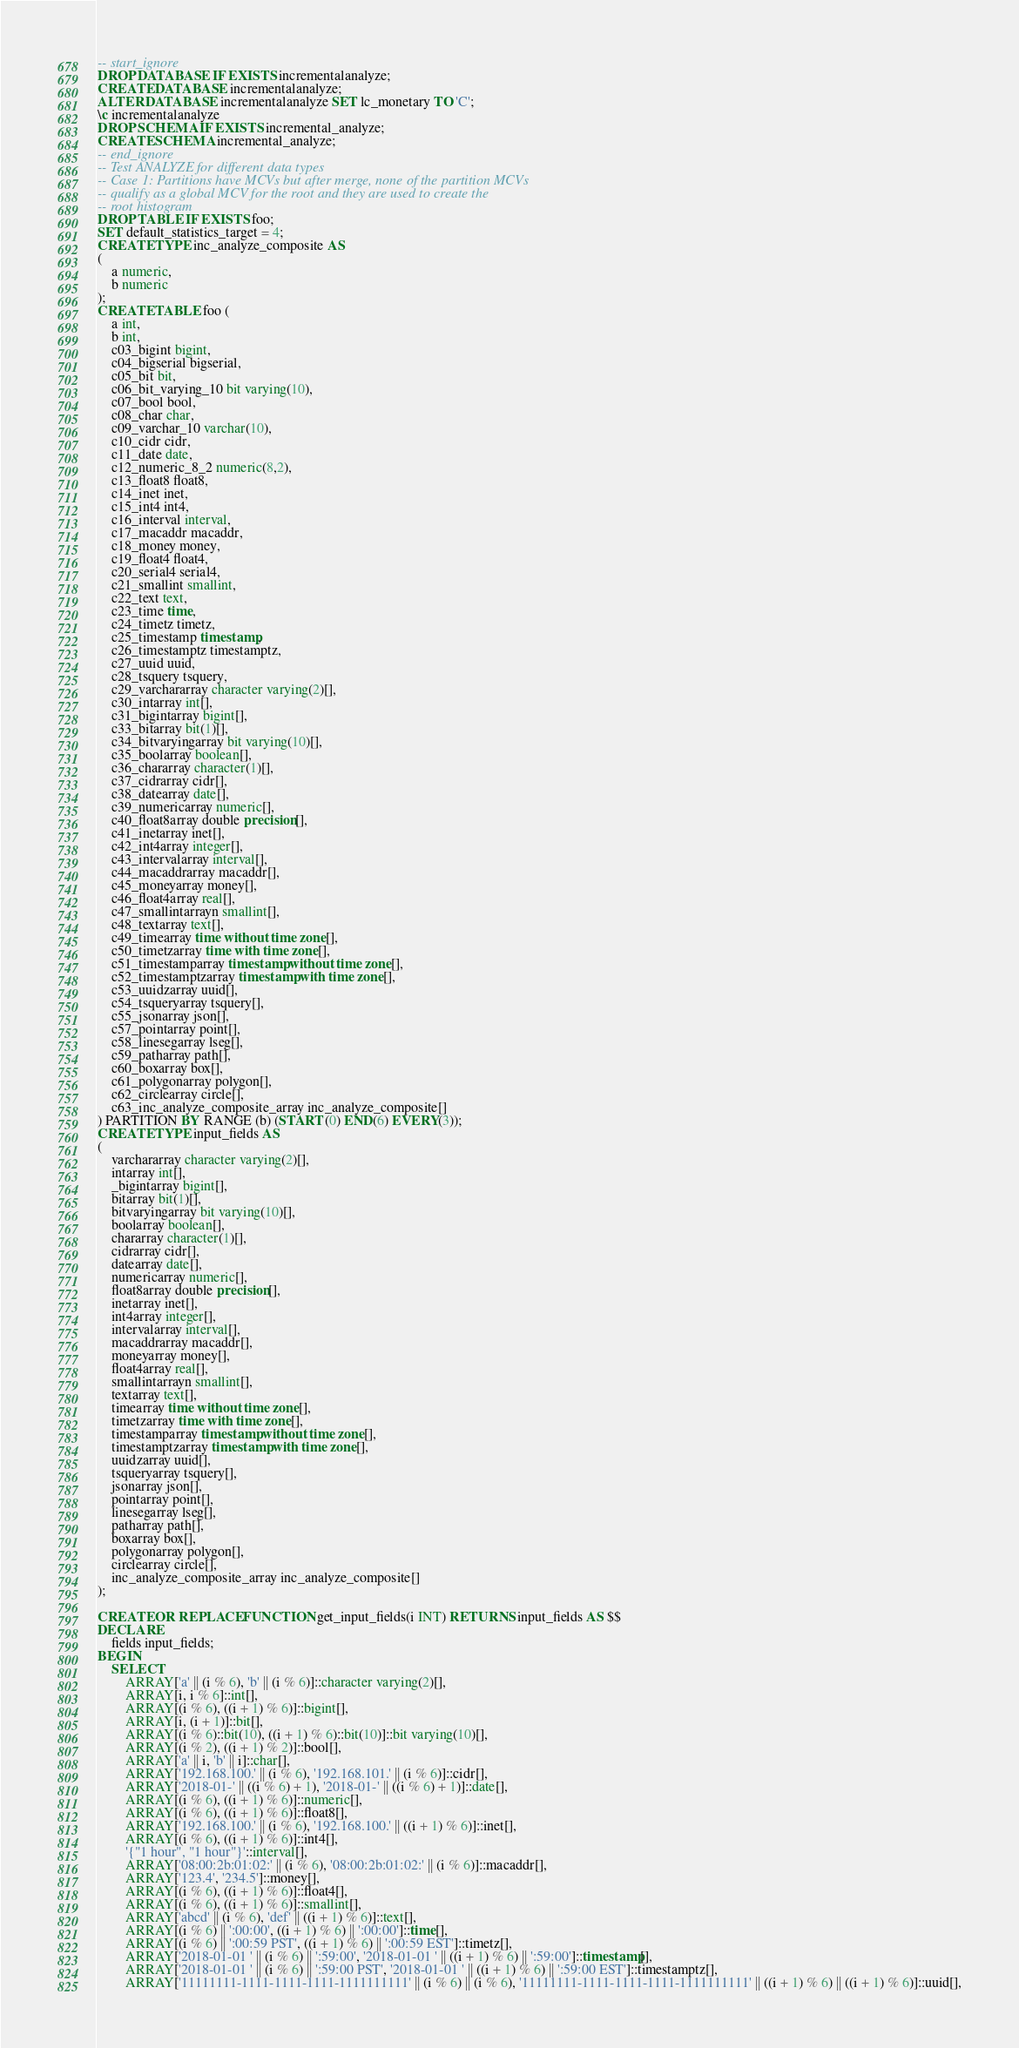Convert code to text. <code><loc_0><loc_0><loc_500><loc_500><_SQL_>-- start_ignore
DROP DATABASE IF EXISTS incrementalanalyze;
CREATE DATABASE incrementalanalyze;
ALTER DATABASE incrementalanalyze SET lc_monetary TO 'C';
\c incrementalanalyze
DROP SCHEMA IF EXISTS incremental_analyze;
CREATE SCHEMA incremental_analyze;
-- end_ignore
-- Test ANALYZE for different data types
-- Case 1: Partitions have MCVs but after merge, none of the partition MCVs 
-- qualify as a global MCV for the root and they are used to create the
-- root histogram
DROP TABLE IF EXISTS foo;
SET default_statistics_target = 4;
CREATE TYPE inc_analyze_composite AS
(
    a numeric,
    b numeric
);
CREATE TABLE foo (
    a int,
    b int, 
    c03_bigint bigint, 
    c04_bigserial bigserial, 
    c05_bit bit, 
    c06_bit_varying_10 bit varying(10), 
    c07_bool bool, 
    c08_char char, 
    c09_varchar_10 varchar(10), 
    c10_cidr cidr, 
    c11_date date, 
    c12_numeric_8_2 numeric(8,2), 
    c13_float8 float8, 
    c14_inet inet, 
    c15_int4 int4, 
    c16_interval interval, 
    c17_macaddr macaddr, 
    c18_money money, 
    c19_float4 float4, 
    c20_serial4 serial4, 
    c21_smallint smallint, 
    c22_text text, 
    c23_time time, 
    c24_timetz timetz, 
    c25_timestamp timestamp, 
    c26_timestamptz timestamptz,
    c27_uuid uuid,
    c28_tsquery tsquery,
    c29_varchararray character varying(2)[],
    c30_intarray int[],
    c31_bigintarray bigint[],
    c33_bitarray bit(1)[],
    c34_bitvaryingarray bit varying(10)[],
    c35_boolarray boolean[],
    c36_chararray character(1)[],
    c37_cidrarray cidr[],
    c38_datearray date[],
    c39_numericarray numeric[],
    c40_float8array double precision[],
    c41_inetarray inet[],
    c42_int4array integer[],
    c43_intervalarray interval[],
    c44_macaddrarray macaddr[],
    c45_moneyarray money[],
    c46_float4array real[],
    c47_smallintarrayn smallint[],
    c48_textarray text[],
    c49_timearray time without time zone[],
    c50_timetzarray time with time zone[],
    c51_timestamparray timestamp without time zone[],
    c52_timestamptzarray timestamp with time zone[],
    c53_uuidzarray uuid[],
    c54_tsqueryarray tsquery[],
    c55_jsonarray json[],
    c57_pointarray point[],
    c58_linesegarray lseg[],
    c59_patharray path[],
    c60_boxarray box[],
    c61_polygonarray polygon[],
    c62_circlearray circle[],
    c63_inc_analyze_composite_array inc_analyze_composite[]
) PARTITION BY RANGE (b) (START (0) END(6) EVERY(3));
CREATE TYPE input_fields AS
(
    varchararray character varying(2)[],
    intarray int[],
    _bigintarray bigint[],
    bitarray bit(1)[],
    bitvaryingarray bit varying(10)[],
    boolarray boolean[],
    chararray character(1)[],
    cidrarray cidr[],
    datearray date[],
    numericarray numeric[],
    float8array double precision[],
    inetarray inet[],
    int4array integer[],
    intervalarray interval[],
    macaddrarray macaddr[],
    moneyarray money[],
    float4array real[],
    smallintarrayn smallint[],
    textarray text[],
    timearray time without time zone[],
    timetzarray time with time zone[],
    timestamparray timestamp without time zone[],
    timestamptzarray timestamp with time zone[],
    uuidzarray uuid[],
    tsqueryarray tsquery[],
    jsonarray json[],
    pointarray point[],
    linesegarray lseg[],
    patharray path[],
    boxarray box[],
    polygonarray polygon[],
    circlearray circle[],
    inc_analyze_composite_array inc_analyze_composite[]
);

CREATE OR REPLACE FUNCTION get_input_fields(i INT) RETURNS input_fields AS $$
DECLARE
    fields input_fields;
BEGIN
    SELECT
        ARRAY['a' || (i % 6), 'b' || (i % 6)]::character varying(2)[],
        ARRAY[i, i % 6]::int[],
        ARRAY[(i % 6), ((i + 1) % 6)]::bigint[],
        ARRAY[i, (i + 1)]::bit[],
        ARRAY[(i % 6)::bit(10), ((i + 1) % 6)::bit(10)]::bit varying(10)[],
        ARRAY[(i % 2), ((i + 1) % 2)]::bool[],
        ARRAY['a' || i, 'b' || i]::char[],
        ARRAY['192.168.100.' || (i % 6), '192.168.101.' || (i % 6)]::cidr[],
        ARRAY['2018-01-' || ((i % 6) + 1), '2018-01-' || ((i % 6) + 1)]::date[],
        ARRAY[(i % 6), ((i + 1) % 6)]::numeric[],
        ARRAY[(i % 6), ((i + 1) % 6)]::float8[],
        ARRAY['192.168.100.' || (i % 6), '192.168.100.' || ((i + 1) % 6)]::inet[],
        ARRAY[(i % 6), ((i + 1) % 6)]::int4[],
        '{"1 hour", "1 hour"}'::interval[],
        ARRAY['08:00:2b:01:02:' || (i % 6), '08:00:2b:01:02:' || (i % 6)]::macaddr[],
        ARRAY['123.4', '234.5']::money[],
        ARRAY[(i % 6), ((i + 1) % 6)]::float4[],
        ARRAY[(i % 6), ((i + 1) % 6)]::smallint[],
        ARRAY['abcd' || (i % 6), 'def' || ((i + 1) % 6)]::text[],
        ARRAY[(i % 6) || ':00:00', ((i + 1) % 6) || ':00:00']::time[],
        ARRAY[(i % 6) || ':00:59 PST', ((i + 1) % 6) || ':00:59 EST']::timetz[],
        ARRAY['2018-01-01 ' || (i % 6) || ':59:00', '2018-01-01 ' || ((i + 1) % 6) || ':59:00']::timestamp[],
        ARRAY['2018-01-01 ' || (i % 6) || ':59:00 PST', '2018-01-01 ' || ((i + 1) % 6) || ':59:00 EST']::timestamptz[],
        ARRAY['11111111-1111-1111-1111-1111111111' || (i % 6) || (i % 6), '11111111-1111-1111-1111-1111111111' || ((i + 1) % 6) || ((i + 1) % 6)]::uuid[],</code> 